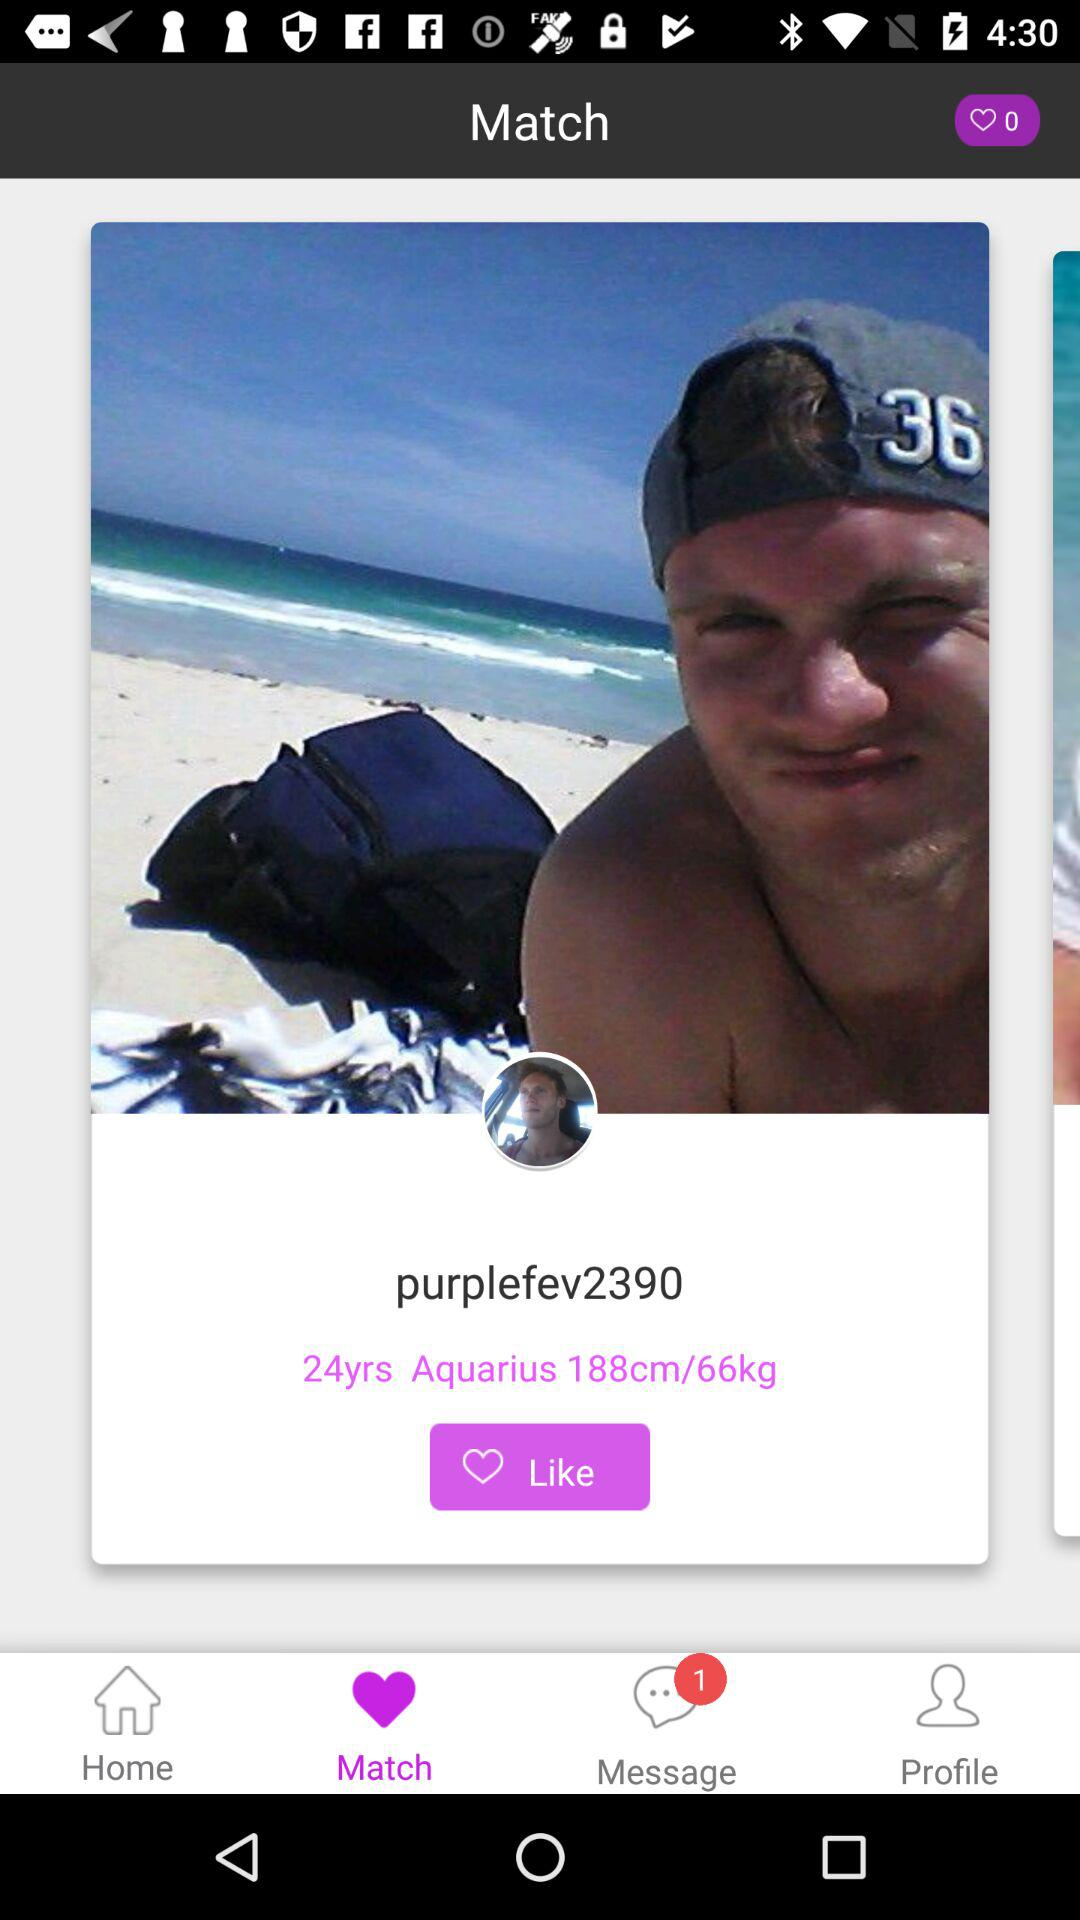What is the number of likes? The number of likes is zero. 